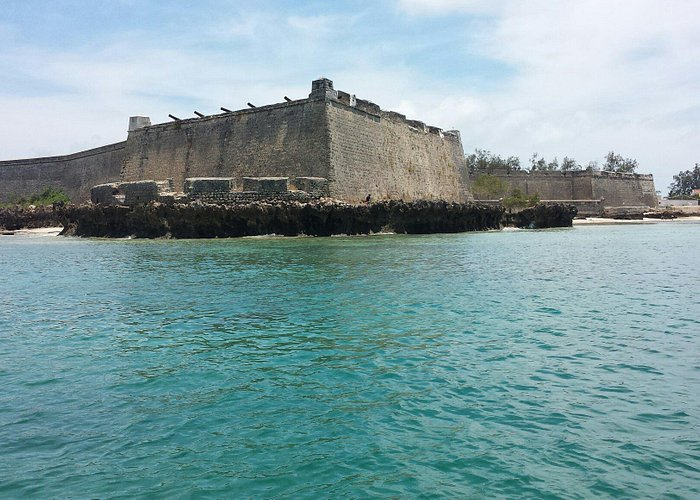Describe this place during a stormy weather. During stormy weather, the Fort of São Sebastião would take on an entirely different character. The clear blue sky would give way to dark, menacing clouds, casting an ominous shadow over the fortress. Fierce waves would crash against the rocky shore, sending sprays of saltwater high into the air. The wind would howl, whipping past the stone walls with a sense of unrestrained fury. The once tranquil turquoise waters would churn violently, and raindrops would pelt the fort's ancient stones. Inside, the sound of the storm would echo through the chambers, a reminder of nature’s untamed power against the backdrop of human history. Create a poetic description of the fort under the moonlight. Under the silvery gaze of the moon, the Fort of São Sebastião transforms into a realm of ethereal beauty. The ancient stones, bathed in gentle moonlight, shimmer softly, their rugged edges softened by the night. Shadows play lovingly along the walls, whispering secrets of bygone eras. The ocean, a mirror of midnight blue, gently lulls against the timeworn ramparts, as if serenading the fortress with lullabies of the deep. A tranquil breeze, carrying the scent of brine and history, meanders through the fort, rustling the spirits of those long gone. In this serene nocturne, the fort stands not as a relic of the past, but as a timeless guardian, cradled in the tender embrace of the moon and sea. Imagine a magical festival being held at the fort; what would it look like? Imagine a magical festival bringing the Fort of São Sebastião to life under a canopy of twinkling fairy lights. The fortress walls are adorned with vibrant banners and lanterns casting a soft, enchanting glow. Colorful stalls line the interior, offering a delightful array of local delicacies, crafted goods, and historical artifacts. Musicians play traditional tunes, their melodies intertwining with the gentle sound of waves lapping against the fort's base. Performers, garbed in rich historical costumes, reenact tales of the fort's storied past, captivating the audience with their spirited portrayals. Children, faces painted with intricate designs, dash about in glee, their laughter filling the air. As night falls, a grand fireworks display lights up the sky, reflected in the calm waters below, celebrating the enduring spirit of the fort and the rich cultural tapestry of Mozambique Island. Describe a scenario where the fort is being used as a filming location for a historical movie. As a filming location for a historical movie, the Fort of São Sebastião is bustling with activity. The serene landscapes are transformed with set pieces that recreate the fort's past glory. Actors dressed in period costumes move across the grounds, bringing history to life with every scene. Cameras and lights are strategically placed to capture the fort's imposing structure and scenic surroundings. Directors and production staff hustle about, ensuring every detail is perfect. The air buzzes with the energy of the crew and the excitement of making a film that will transport audiences back in time, using the fort’s authentic backdrop to add depth and realism to the story. 